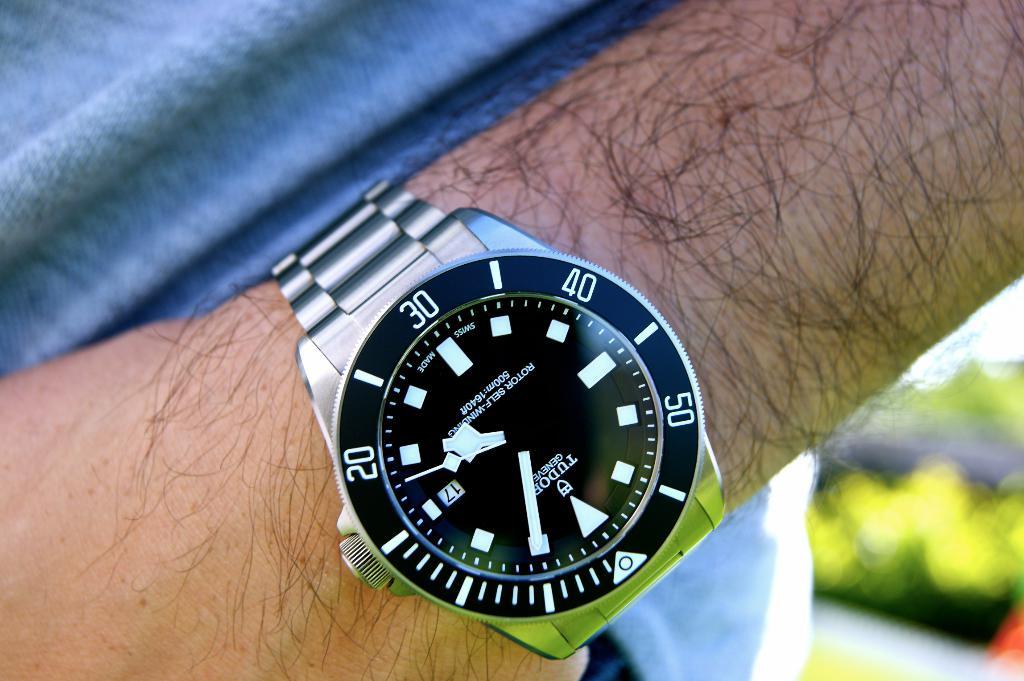What day of the month is it?
Provide a short and direct response. 17. 